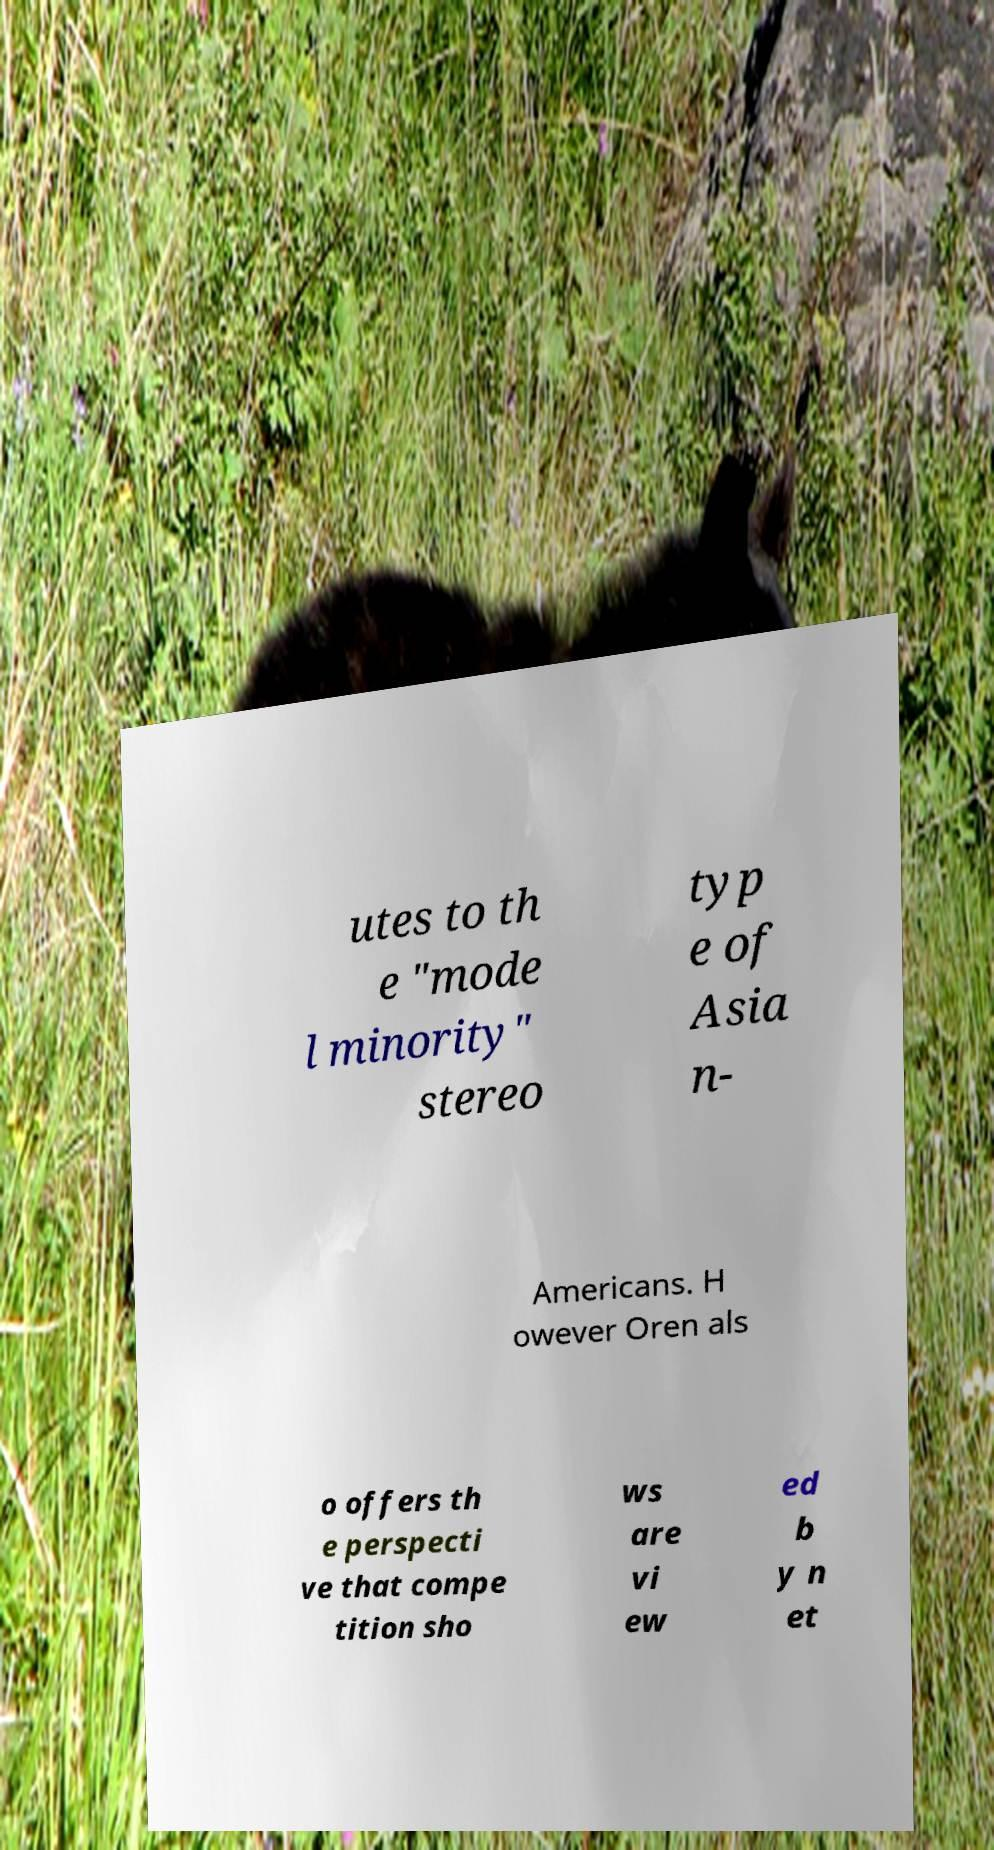Could you extract and type out the text from this image? utes to th e "mode l minority" stereo typ e of Asia n- Americans. H owever Oren als o offers th e perspecti ve that compe tition sho ws are vi ew ed b y n et 